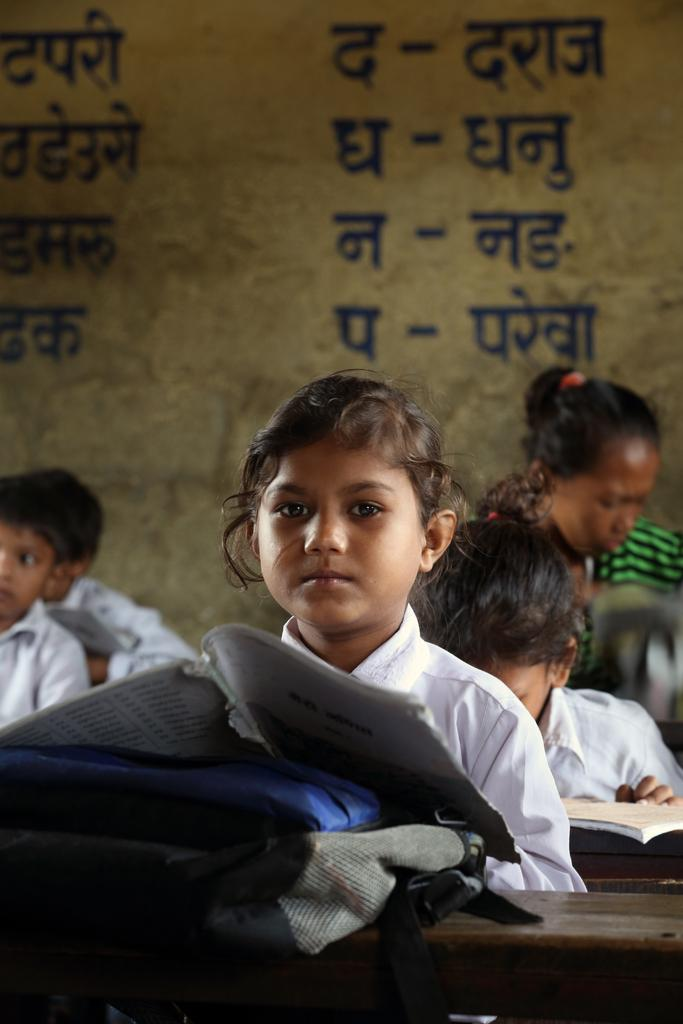What is the girl in the image holding? The girl in the image is holding a school bag. Where is the girl sitting in the image? The girl is sitting in front of a desk in the image. Can you describe the setting of the image? The image shows a girl sitting at a desk, with many other girls visible in the background. What type of powder is being used by the pig in the image? There is no pig or powder present in the image. 